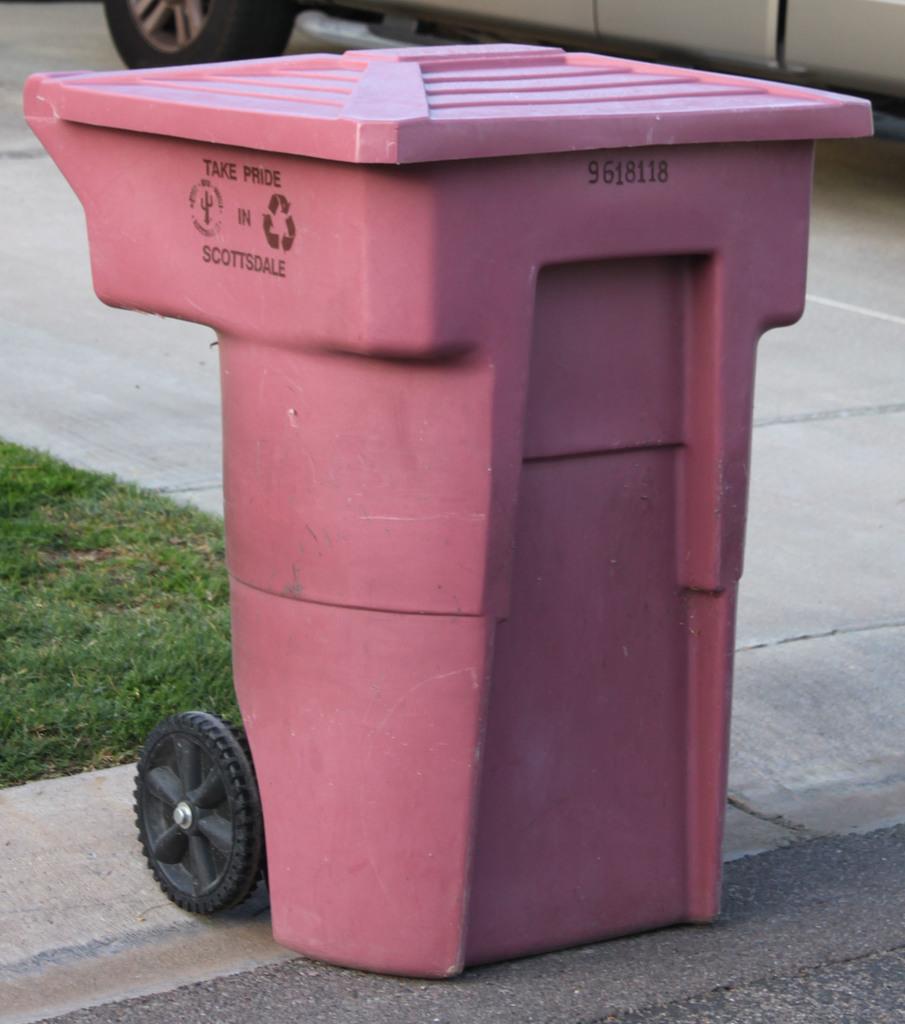Which city does the trash can belong to?
Offer a very short reply. Scottsdale. Take what in scottsdale?
Provide a succinct answer. Pride. 